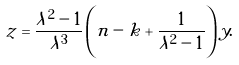Convert formula to latex. <formula><loc_0><loc_0><loc_500><loc_500>z = \frac { \lambda ^ { 2 } - 1 } { \lambda ^ { 3 } } \left ( n - k + \frac { 1 } { \lambda ^ { 2 } - 1 } \right ) y .</formula> 